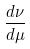<formula> <loc_0><loc_0><loc_500><loc_500>\frac { d \nu } { d \mu }</formula> 